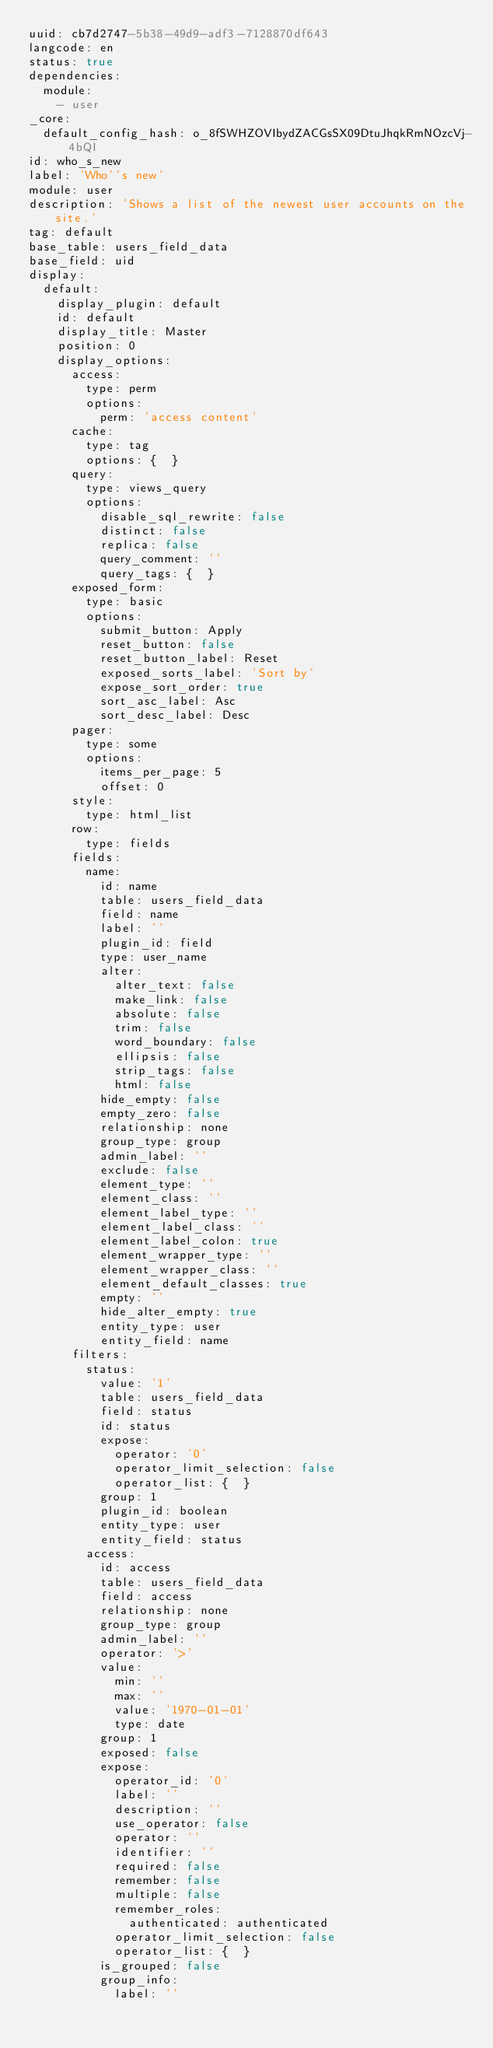<code> <loc_0><loc_0><loc_500><loc_500><_YAML_>uuid: cb7d2747-5b38-49d9-adf3-7128870df643
langcode: en
status: true
dependencies:
  module:
    - user
_core:
  default_config_hash: o_8fSWHZOVIbydZACGsSX09DtuJhqkRmNOzcVj-4bQI
id: who_s_new
label: 'Who''s new'
module: user
description: 'Shows a list of the newest user accounts on the site.'
tag: default
base_table: users_field_data
base_field: uid
display:
  default:
    display_plugin: default
    id: default
    display_title: Master
    position: 0
    display_options:
      access:
        type: perm
        options:
          perm: 'access content'
      cache:
        type: tag
        options: {  }
      query:
        type: views_query
        options:
          disable_sql_rewrite: false
          distinct: false
          replica: false
          query_comment: ''
          query_tags: {  }
      exposed_form:
        type: basic
        options:
          submit_button: Apply
          reset_button: false
          reset_button_label: Reset
          exposed_sorts_label: 'Sort by'
          expose_sort_order: true
          sort_asc_label: Asc
          sort_desc_label: Desc
      pager:
        type: some
        options:
          items_per_page: 5
          offset: 0
      style:
        type: html_list
      row:
        type: fields
      fields:
        name:
          id: name
          table: users_field_data
          field: name
          label: ''
          plugin_id: field
          type: user_name
          alter:
            alter_text: false
            make_link: false
            absolute: false
            trim: false
            word_boundary: false
            ellipsis: false
            strip_tags: false
            html: false
          hide_empty: false
          empty_zero: false
          relationship: none
          group_type: group
          admin_label: ''
          exclude: false
          element_type: ''
          element_class: ''
          element_label_type: ''
          element_label_class: ''
          element_label_colon: true
          element_wrapper_type: ''
          element_wrapper_class: ''
          element_default_classes: true
          empty: ''
          hide_alter_empty: true
          entity_type: user
          entity_field: name
      filters:
        status:
          value: '1'
          table: users_field_data
          field: status
          id: status
          expose:
            operator: '0'
            operator_limit_selection: false
            operator_list: {  }
          group: 1
          plugin_id: boolean
          entity_type: user
          entity_field: status
        access:
          id: access
          table: users_field_data
          field: access
          relationship: none
          group_type: group
          admin_label: ''
          operator: '>'
          value:
            min: ''
            max: ''
            value: '1970-01-01'
            type: date
          group: 1
          exposed: false
          expose:
            operator_id: '0'
            label: ''
            description: ''
            use_operator: false
            operator: ''
            identifier: ''
            required: false
            remember: false
            multiple: false
            remember_roles:
              authenticated: authenticated
            operator_limit_selection: false
            operator_list: {  }
          is_grouped: false
          group_info:
            label: ''</code> 